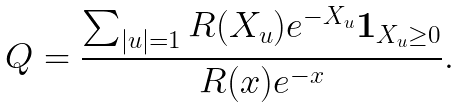<formula> <loc_0><loc_0><loc_500><loc_500>Q = \frac { \sum _ { | u | = 1 } R ( X _ { u } ) e ^ { - X _ { u } } \boldsymbol 1 _ { X _ { u } \geq 0 } } { R ( x ) e ^ { - x } } .</formula> 